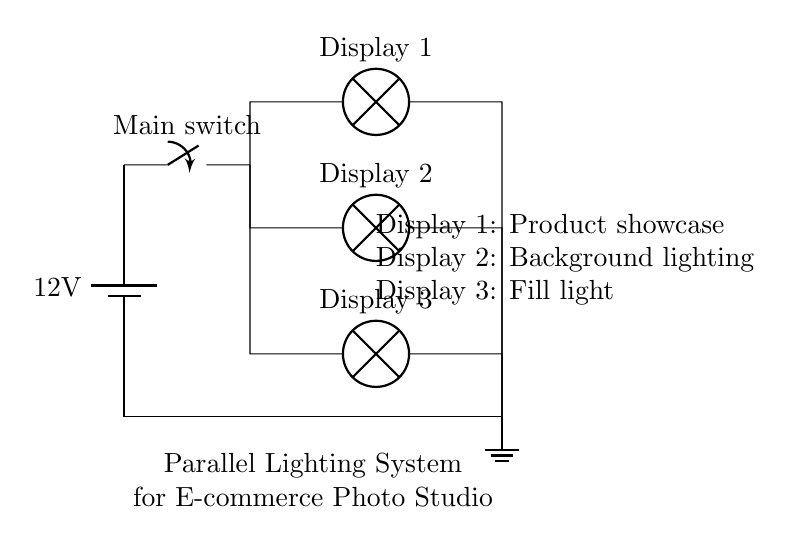What is the voltage supply in this circuit? The circuit shows a battery labeled with a voltage of 12 volts, which is the supply voltage for the entire lighting system.
Answer: 12 volts How many lamps are connected in parallel? The diagram illustrates three distinct lamps connected in parallel branches. Each lamp represents a separate path for current.
Answer: Three What are the functions of the lamps in this circuit? The circuit diagram indicates that Display 1 is for product showcase, Display 2 serves as background lighting, and Display 3 acts as fill light. Each lamp has a specific purpose indicated in the labels adjacent to them.
Answer: Product showcase, background lighting, fill light What would happen if one lamp fails in this parallel lighting system? In a parallel circuit, if one lamp fails, the other lamps will continue to function since they have their own independent paths for current. Therefore, the other displays would not be affected by the failure of one lamp.
Answer: Other lamps stay lit What is the main switch used for in this circuit? The main switch controls the activation and deactivation of the entire lighting system. When opened, it breaks the connection, preventing current flow to all lamps; when closed, it allows current to flow to the lamps.
Answer: Controls power to all lamps Which lamp is closest to the power supply? Display 1 is the first lamp connected after the main switch in the parallel configuration, indicating it is the closest to the power supply in terms of circuit path.
Answer: Display 1 